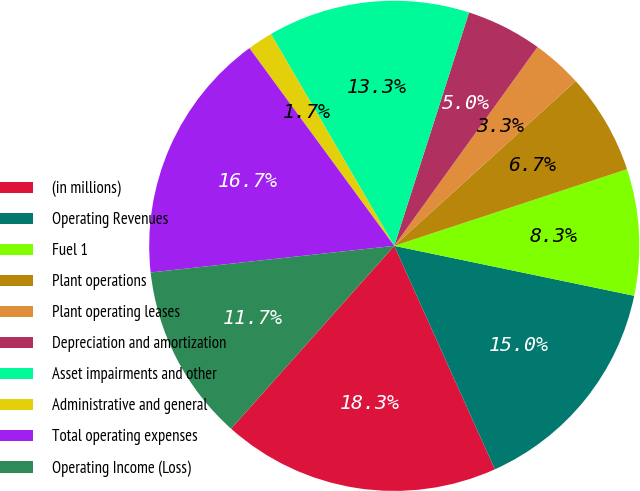<chart> <loc_0><loc_0><loc_500><loc_500><pie_chart><fcel>(in millions)<fcel>Operating Revenues<fcel>Fuel 1<fcel>Plant operations<fcel>Plant operating leases<fcel>Depreciation and amortization<fcel>Asset impairments and other<fcel>Administrative and general<fcel>Total operating expenses<fcel>Operating Income (Loss)<nl><fcel>18.33%<fcel>15.0%<fcel>8.33%<fcel>6.67%<fcel>3.33%<fcel>5.0%<fcel>13.33%<fcel>1.67%<fcel>16.67%<fcel>11.67%<nl></chart> 